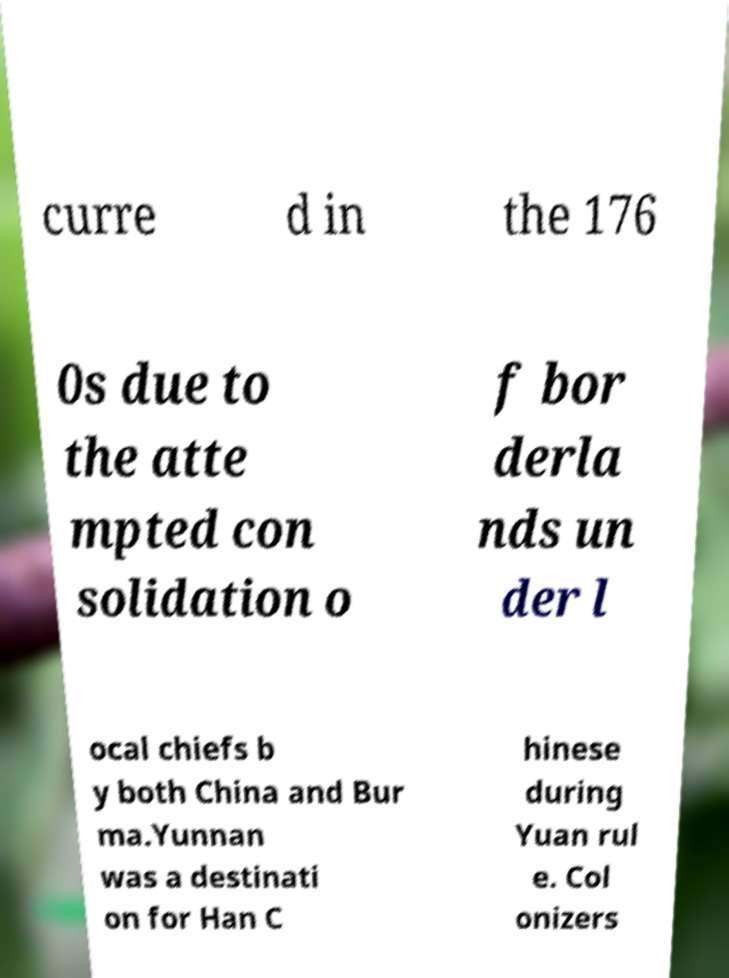For documentation purposes, I need the text within this image transcribed. Could you provide that? curre d in the 176 0s due to the atte mpted con solidation o f bor derla nds un der l ocal chiefs b y both China and Bur ma.Yunnan was a destinati on for Han C hinese during Yuan rul e. Col onizers 